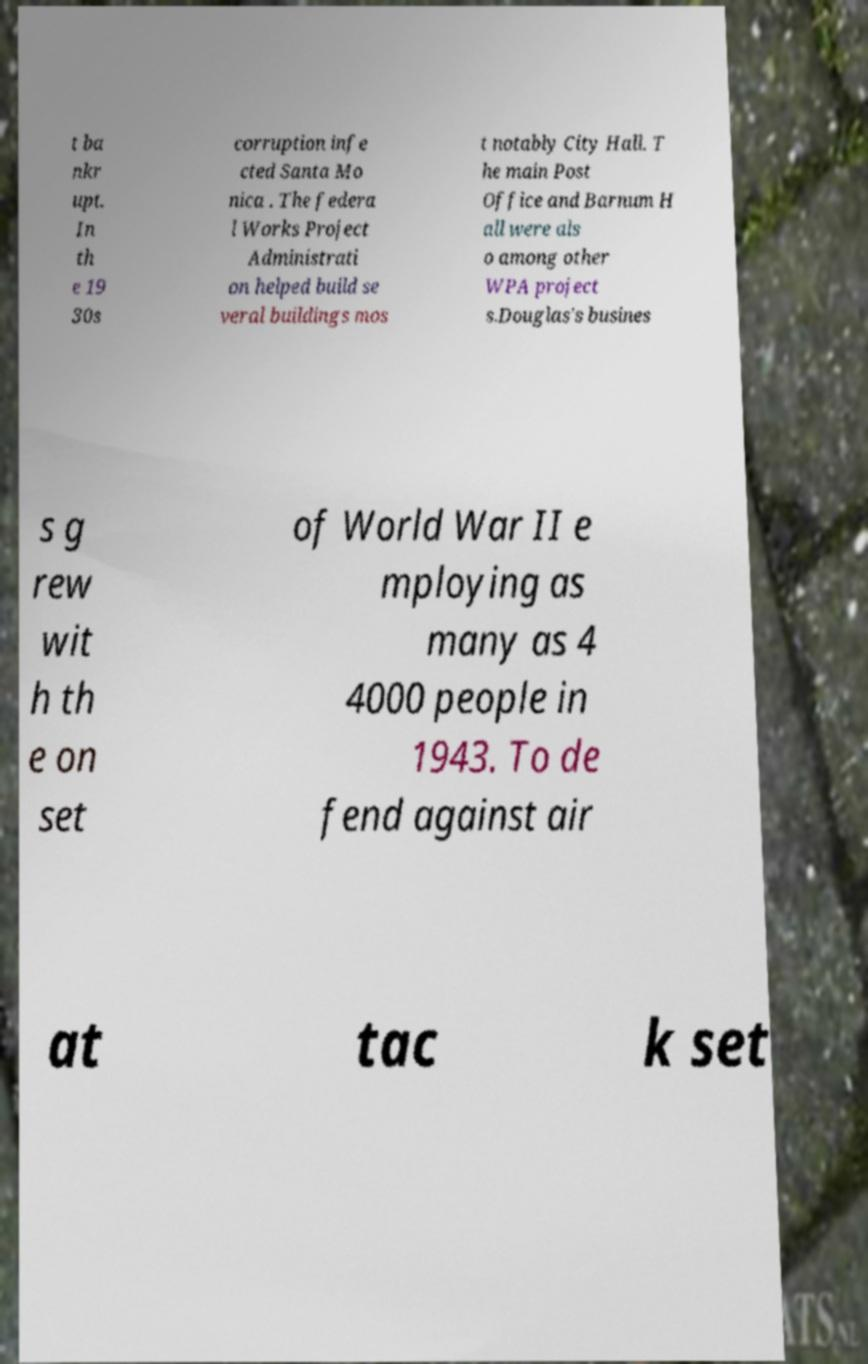What messages or text are displayed in this image? I need them in a readable, typed format. t ba nkr upt. In th e 19 30s corruption infe cted Santa Mo nica . The federa l Works Project Administrati on helped build se veral buildings mos t notably City Hall. T he main Post Office and Barnum H all were als o among other WPA project s.Douglas's busines s g rew wit h th e on set of World War II e mploying as many as 4 4000 people in 1943. To de fend against air at tac k set 